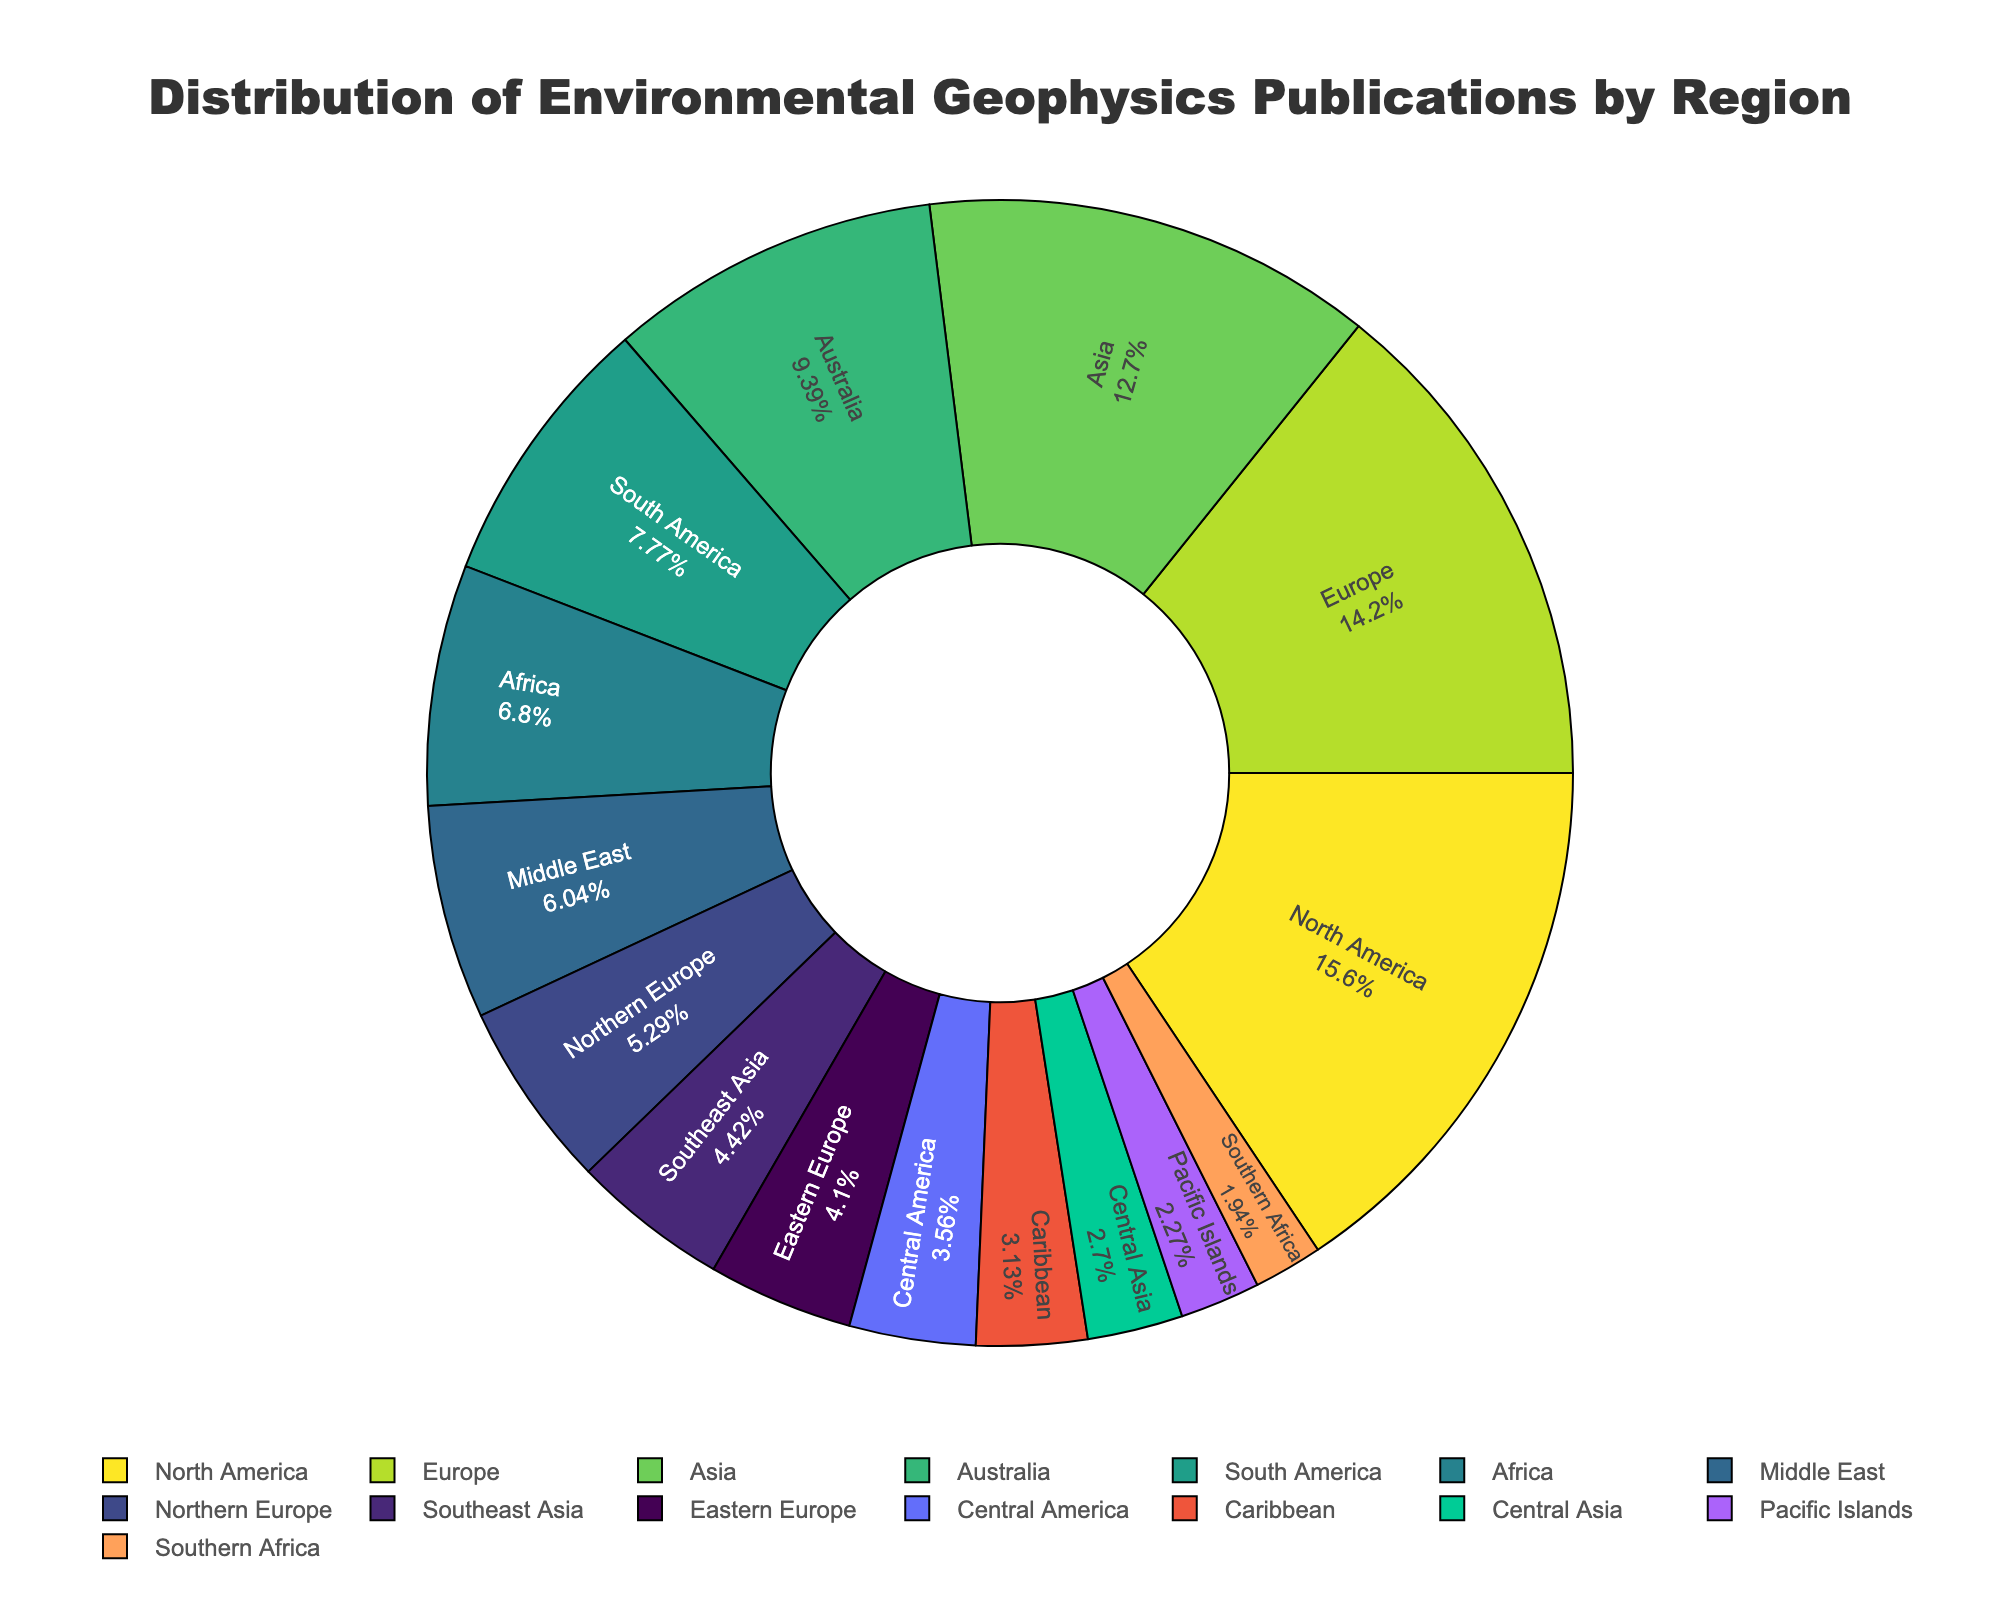Which region has the highest percentage of environmental geophysics publications? By analyzing the pie chart, identify the region with the largest segment.
Answer: North America What is the combined percentage of publications for Asia and Europe? First, find the individual percentages of publications for Asia and Europe. Add these percentages together to get the combined percentage.
Answer: Approximately 45% Which region has fewer publications: South America or Africa? Compare the sizes of the segments for South America and Africa in the pie chart. The smaller segment indicates fewer publications.
Answer: Africa How many more publications does North America have compared to Australia? Subtract the number of publications in Australia from the number in North America: 145 - 87 = 58.
Answer: 58 Among the regions with the least publications, which one has slightly more: Central Asia or the Pacific Islands? Compare the segments representing Central Asia and the Pacific Islands in the pie chart. The one with the slightly larger segment has more publications.
Answer: Central Asia What is the median number of publications among all regions? First, list all publication numbers in ascending order. The median is the middle value in this ordered list.
Answer: 49 If we combine the publications from Europe, Asia, and Australia, what percentage of the total publications do they represent? Sum the publications from Europe, Asia, and Australia. Divide by the total publications, then multiply by 100 to get the percentage: (132 + 118 + 87)/828 * 100 ≈ 40.1%.
Answer: Approximately 40.1% Is there a region whose publications are equal to the average number of publications across all regions? Calculate the average number of publications by dividing the total number of publications by the number of regions. Then, check if any region matches this value: 828 / 15 = 55.2. None of the regions have exactly 55.2 publications.
Answer: No Which region has the closest number of publications to 50? From the pie chart, identify the region with the publication number closest to 50 by checking the actual values against 50.
Answer: Northern Europe 